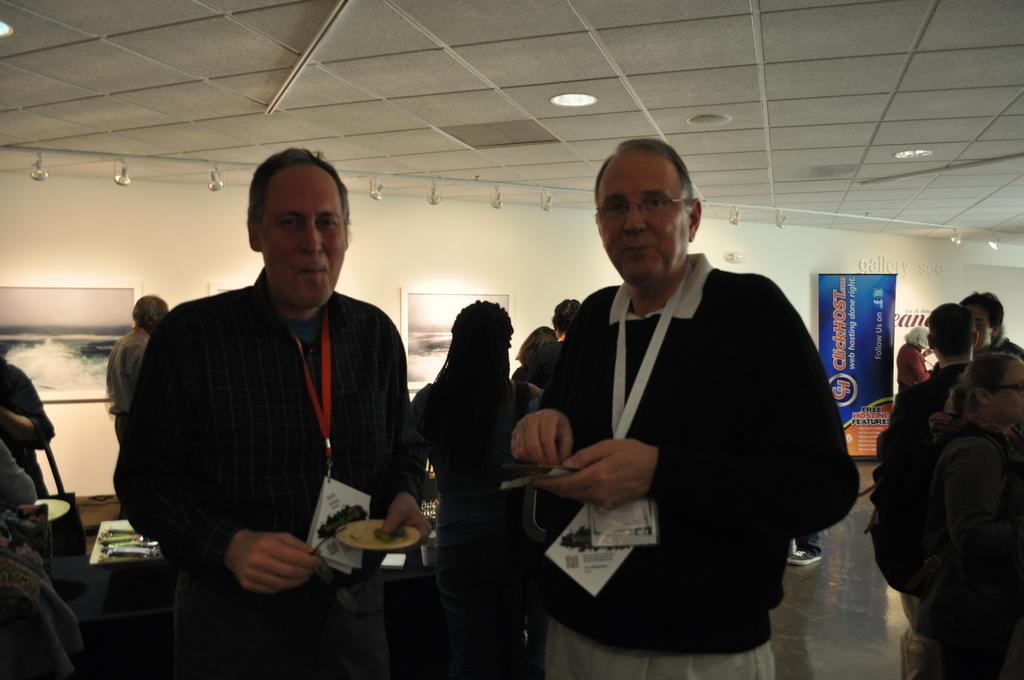How many men are present in the image? There are two men standing in the image. What is the facial expression of the men? The men are smiling. What can be seen in the background of the image? There is a group of people and a banner visible in the background. What is on the wall in the background? There are frames on the wall in the background. What type of parcel is being delivered to the men in the image? There is no parcel being delivered to the men in the image. Can you see any ants crawling on the men in the image? There are no ants visible in the image. 